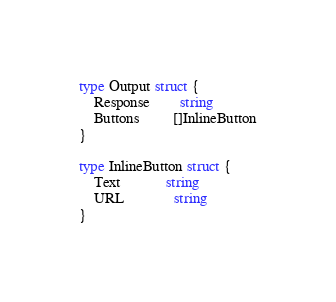Convert code to text. <code><loc_0><loc_0><loc_500><loc_500><_Go_>type Output struct {
	Response        string
	Buttons         []InlineButton
}

type InlineButton struct {
	Text            string
	URL             string
}
</code> 